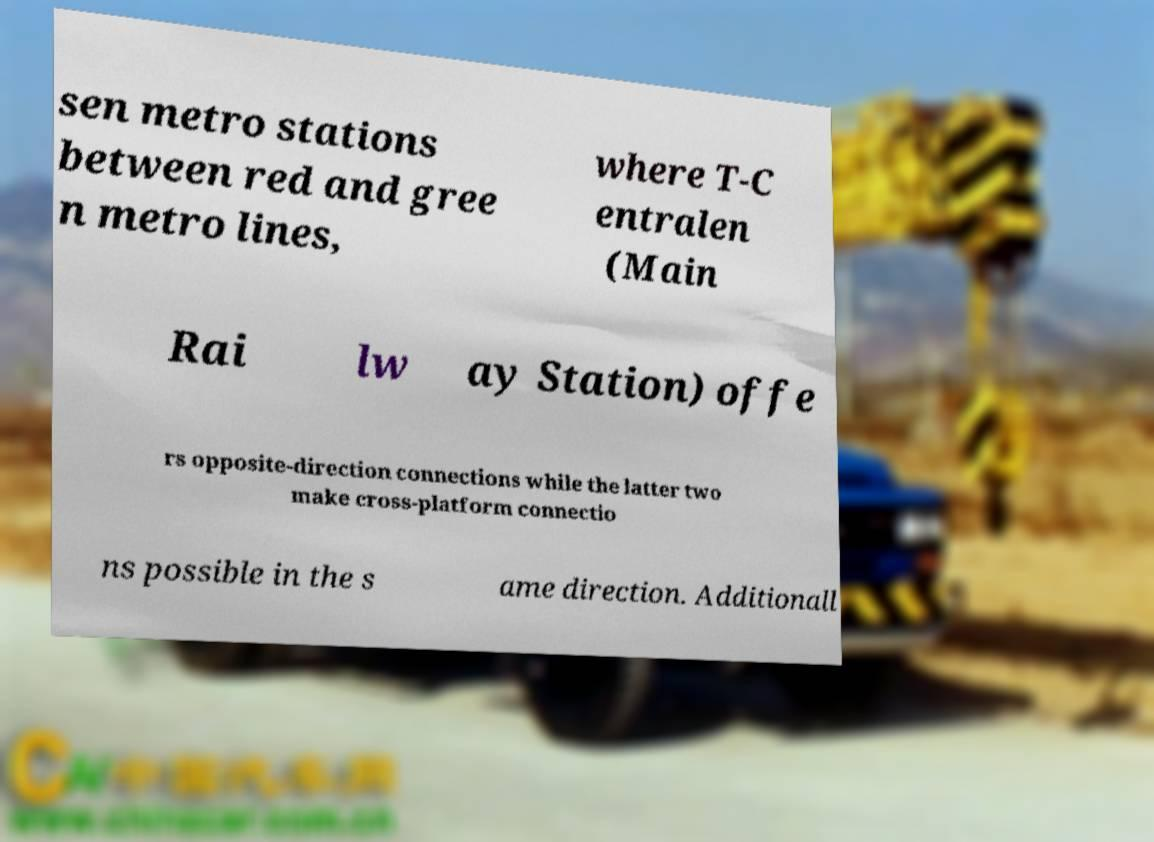There's text embedded in this image that I need extracted. Can you transcribe it verbatim? sen metro stations between red and gree n metro lines, where T-C entralen (Main Rai lw ay Station) offe rs opposite-direction connections while the latter two make cross-platform connectio ns possible in the s ame direction. Additionall 